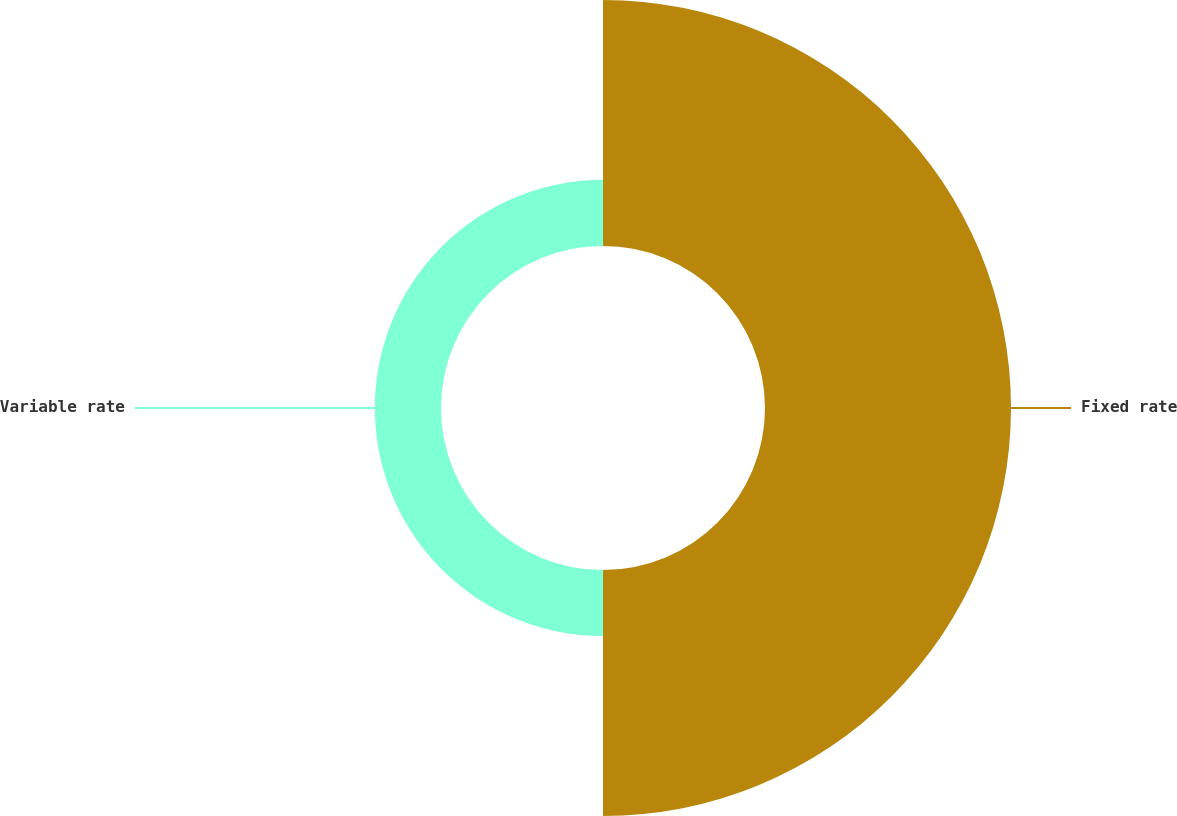Convert chart to OTSL. <chart><loc_0><loc_0><loc_500><loc_500><pie_chart><fcel>Fixed rate<fcel>Variable rate<nl><fcel>78.8%<fcel>21.2%<nl></chart> 